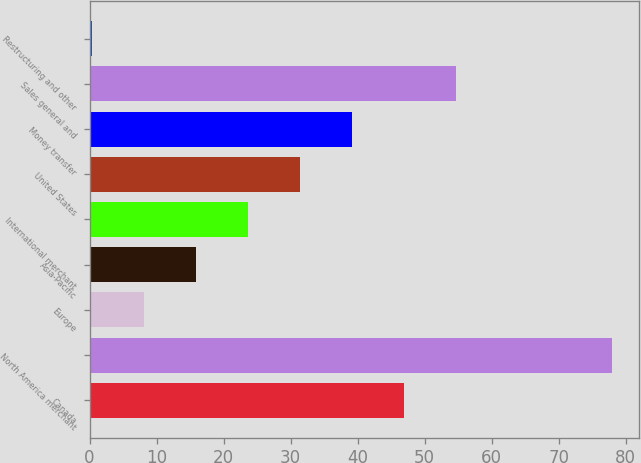<chart> <loc_0><loc_0><loc_500><loc_500><bar_chart><fcel>Canada<fcel>North America merchant<fcel>Europe<fcel>Asia-Pacific<fcel>International merchant<fcel>United States<fcel>Money transfer<fcel>Sales general and<fcel>Restructuring and other<nl><fcel>46.92<fcel>78<fcel>8.07<fcel>15.84<fcel>23.61<fcel>31.38<fcel>39.15<fcel>54.69<fcel>0.3<nl></chart> 